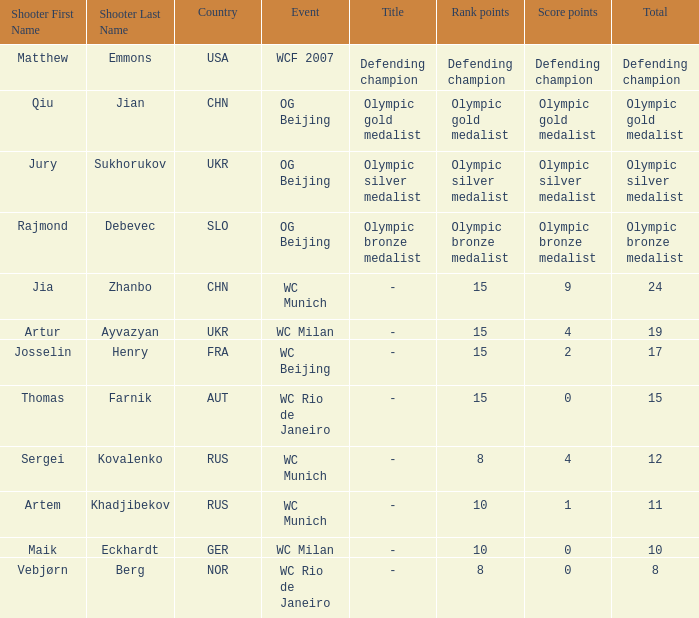With Olympic Bronze Medalist as the total what are the score points? Olympic bronze medalist. 